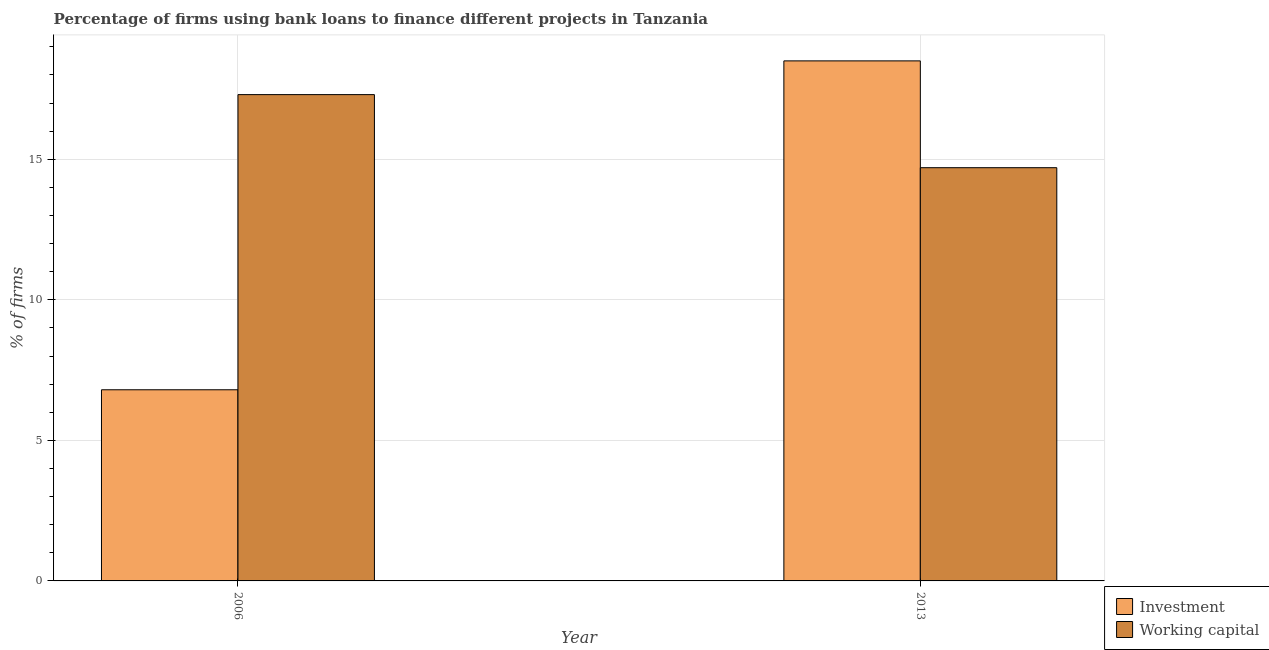How many different coloured bars are there?
Your answer should be compact. 2. How many groups of bars are there?
Your answer should be compact. 2. Are the number of bars per tick equal to the number of legend labels?
Make the answer very short. Yes. Are the number of bars on each tick of the X-axis equal?
Offer a terse response. Yes. In how many cases, is the number of bars for a given year not equal to the number of legend labels?
Provide a short and direct response. 0. Across all years, what is the minimum percentage of firms using banks to finance working capital?
Provide a succinct answer. 14.7. What is the total percentage of firms using banks to finance investment in the graph?
Your response must be concise. 25.3. What is the difference between the percentage of firms using banks to finance working capital in 2006 and that in 2013?
Offer a very short reply. 2.6. What is the difference between the percentage of firms using banks to finance working capital in 2013 and the percentage of firms using banks to finance investment in 2006?
Keep it short and to the point. -2.6. In the year 2013, what is the difference between the percentage of firms using banks to finance investment and percentage of firms using banks to finance working capital?
Your response must be concise. 0. What is the ratio of the percentage of firms using banks to finance investment in 2006 to that in 2013?
Your answer should be very brief. 0.37. Is the percentage of firms using banks to finance investment in 2006 less than that in 2013?
Make the answer very short. Yes. In how many years, is the percentage of firms using banks to finance working capital greater than the average percentage of firms using banks to finance working capital taken over all years?
Your response must be concise. 1. What does the 2nd bar from the left in 2013 represents?
Offer a very short reply. Working capital. What does the 1st bar from the right in 2006 represents?
Offer a terse response. Working capital. Are all the bars in the graph horizontal?
Make the answer very short. No. Does the graph contain grids?
Provide a succinct answer. Yes. How many legend labels are there?
Your response must be concise. 2. What is the title of the graph?
Make the answer very short. Percentage of firms using bank loans to finance different projects in Tanzania. Does "Infant" appear as one of the legend labels in the graph?
Provide a succinct answer. No. What is the label or title of the Y-axis?
Give a very brief answer. % of firms. What is the % of firms of Working capital in 2006?
Your answer should be compact. 17.3. What is the % of firms in Working capital in 2013?
Give a very brief answer. 14.7. Across all years, what is the maximum % of firms of Investment?
Give a very brief answer. 18.5. Across all years, what is the minimum % of firms of Working capital?
Provide a succinct answer. 14.7. What is the total % of firms of Investment in the graph?
Your response must be concise. 25.3. What is the difference between the % of firms of Investment in 2006 and the % of firms of Working capital in 2013?
Your response must be concise. -7.9. What is the average % of firms of Investment per year?
Ensure brevity in your answer.  12.65. What is the average % of firms in Working capital per year?
Make the answer very short. 16. What is the ratio of the % of firms of Investment in 2006 to that in 2013?
Give a very brief answer. 0.37. What is the ratio of the % of firms in Working capital in 2006 to that in 2013?
Your response must be concise. 1.18. What is the difference between the highest and the lowest % of firms of Investment?
Make the answer very short. 11.7. 